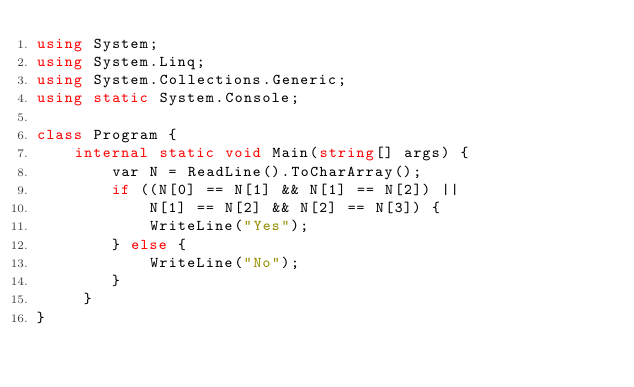<code> <loc_0><loc_0><loc_500><loc_500><_C#_>using System;
using System.Linq;
using System.Collections.Generic;
using static System.Console;

class Program {
    internal static void Main(string[] args) {
        var N = ReadLine().ToCharArray();
        if ((N[0] == N[1] && N[1] == N[2]) ||
            N[1] == N[2] && N[2] == N[3]) {
            WriteLine("Yes");
        } else {
            WriteLine("No");
        }
     }
}</code> 